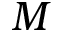<formula> <loc_0><loc_0><loc_500><loc_500>M</formula> 